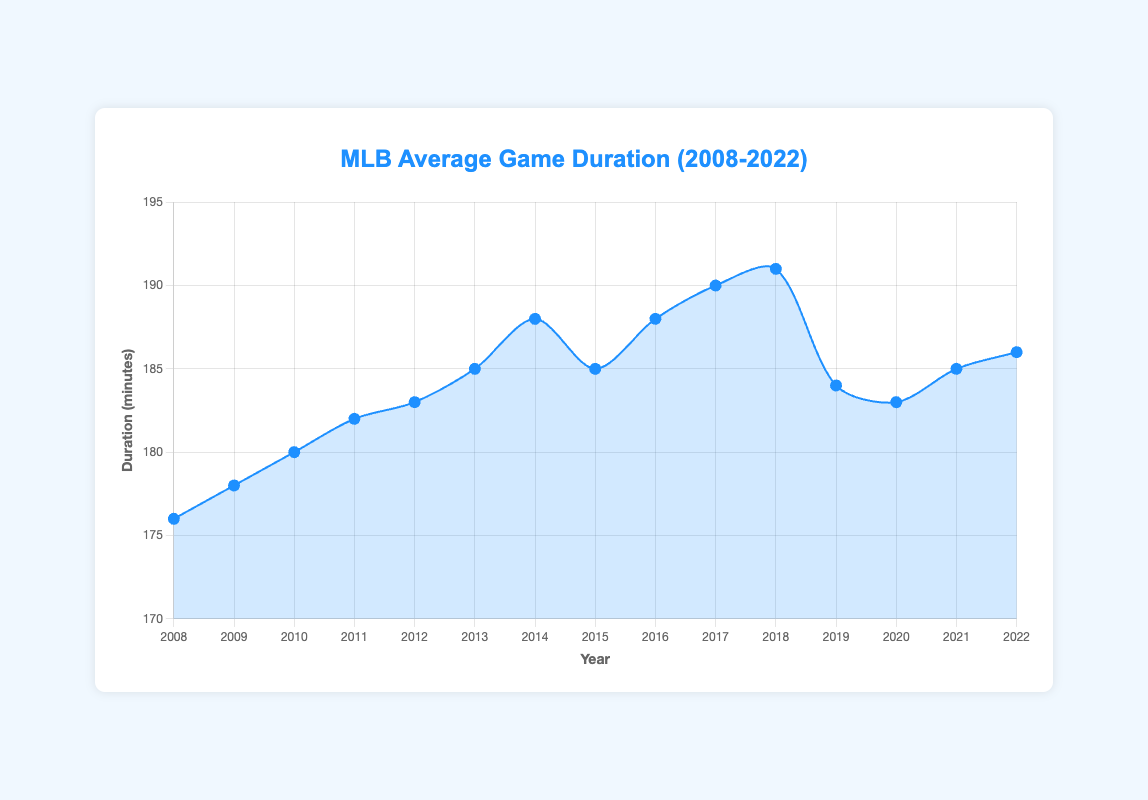When did the average game duration first surpass 180 minutes? By observing the plot, we see that the first time the average game duration surpasses 180 minutes is in 2010.
Answer: 2010 What is the maximum average game duration recorded and in which year did it occur? The highest point on the plot indicates the maximum duration. It is 191 minutes and occurs in 2018.
Answer: 191 minutes, 2018 Which year saw the biggest drop in average game duration compared to the previous year? By examining the downward trends between consecutive years, the largest drop occurs between 2018 (191 minutes) and 2019 (184 minutes). The difference is 7 minutes.
Answer: 2019 Between which consecutive seasons was there no change in the average game duration? A flat line in the plot indicates no change. From 2020 to 2021, the average game duration remained at 185 minutes.
Answer: 2020-2021 How many seasons had an average game duration of exactly 185 minutes? By identifying the points where the value is 185, these are the years 2013, 2015, and 2021.
Answer: 3 seasons What is the average game duration over the 15 seasons presented? Adding up all the average game durations and dividing by the number of seasons: (176+178+180+182+183+185+188+185+188+190+191+184+183+185+186)/15 ≈ 184.5 minutes.
Answer: 184.5 minutes In which years did the average game duration increase consecutively? By tracing the upward-sloping segments of the plot, the consecutive increases are from 2008 to 2014 and from 2016 to 2018.
Answer: 2008-2014, 2016-2018 What is the percentage increase in average game duration from 2008 to 2018? Calculate the difference and divide by the initial value: (191 - 176)/176 * 100 ≈ 8.52%.
Answer: 8.52% What years indicate a shorter average game duration than the year 2022? By comparing each data point to 186 minutes in 2022, these years are 2008, 2009, 2010, 2011, 2012, 2013, 2015, 2019, and 2020.
Answer: 9 years What trend can be observed in the average game duration from 2008 to 2018? Analyzing the overall shape of the plot from 2008 to 2018 shows a general upward trend in game duration, peaking in 2018.
Answer: Upward trend 